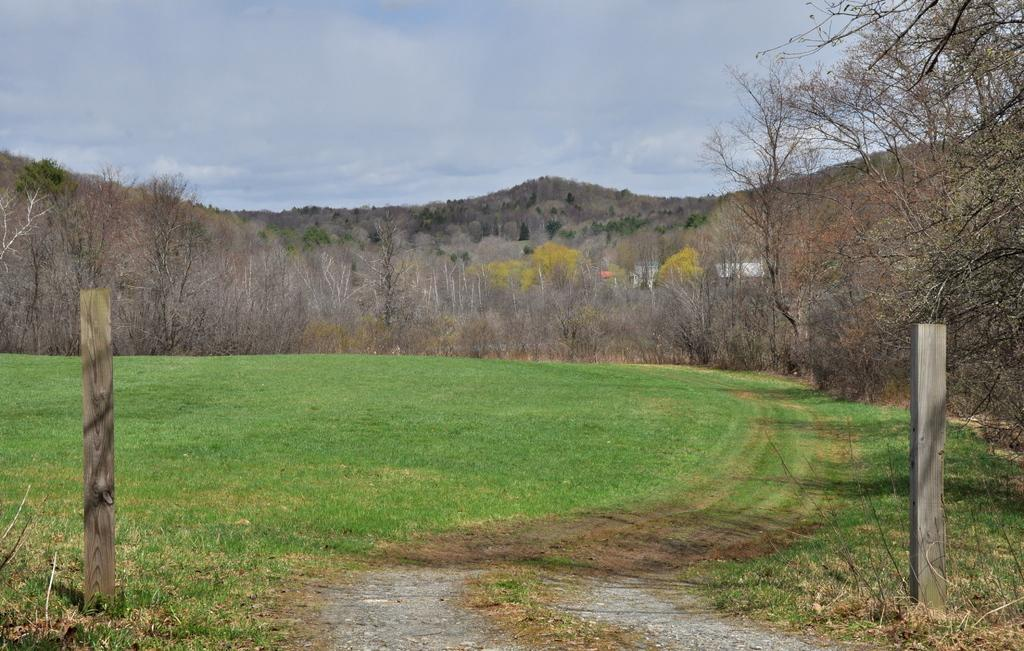What is the main feature of the landscape in the image? There is an open grass ground in the image. What objects can be seen in the foreground of the image? There are two wooden poles in the front of the image. What can be seen in the background of the image? There are trees, buildings, clouds, and the sky visible in the background of the image. What type of amusement can be seen on the grass ground in the image? There is no amusement present on the grass ground in the image. Can you tell me where the mailbox is located in the image? There is no mailbox present in the image. 